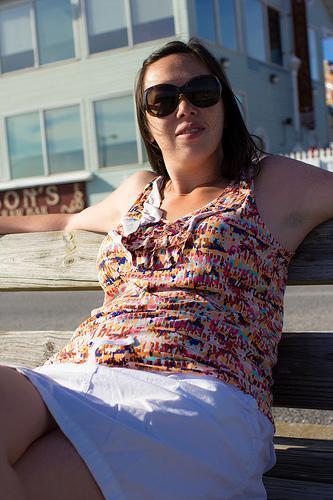How many people can be seen?
Give a very brief answer. 1. 